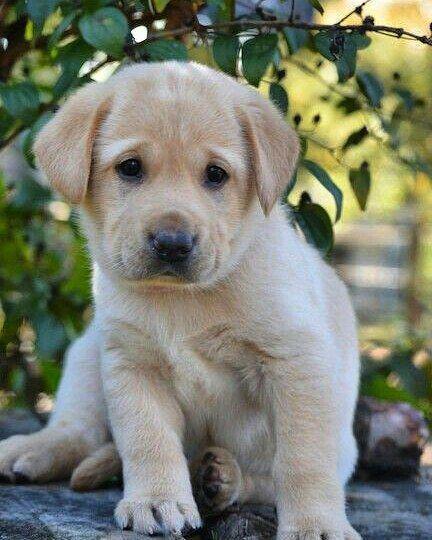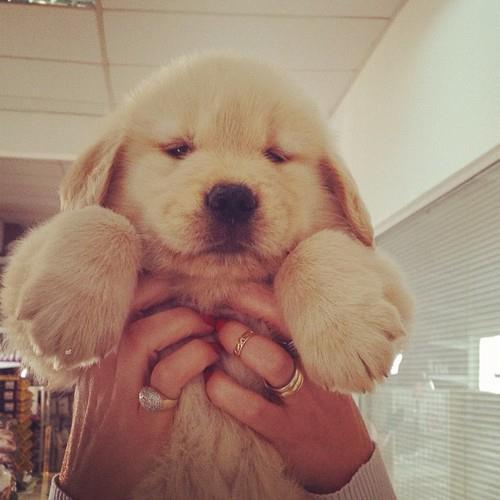The first image is the image on the left, the second image is the image on the right. Given the left and right images, does the statement "There are at least three dogs." hold true? Answer yes or no. No. The first image is the image on the left, the second image is the image on the right. Analyze the images presented: Is the assertion "In one of the images there are at least two puppies right next to each other." valid? Answer yes or no. No. 